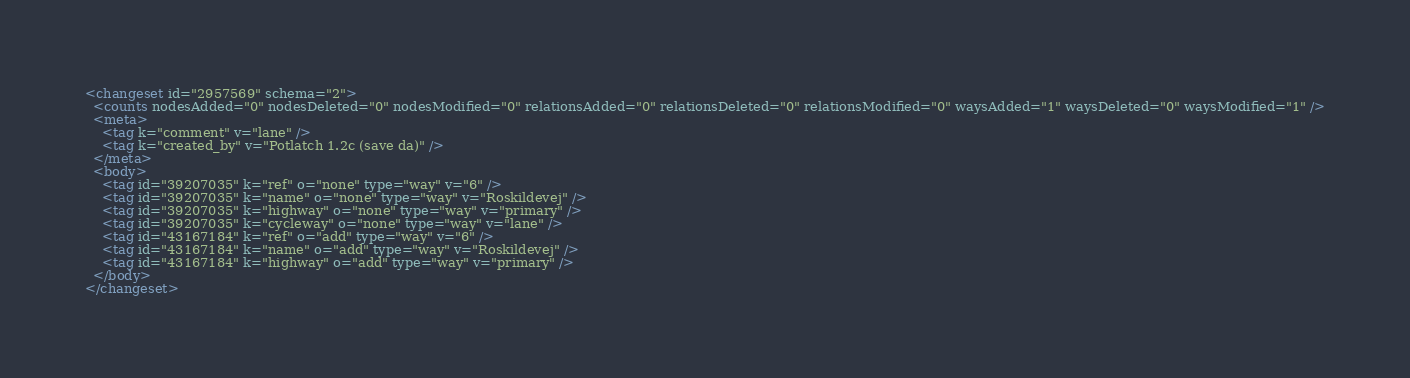<code> <loc_0><loc_0><loc_500><loc_500><_XML_><changeset id="2957569" schema="2">
  <counts nodesAdded="0" nodesDeleted="0" nodesModified="0" relationsAdded="0" relationsDeleted="0" relationsModified="0" waysAdded="1" waysDeleted="0" waysModified="1" />
  <meta>
    <tag k="comment" v="lane" />
    <tag k="created_by" v="Potlatch 1.2c (save da)" />
  </meta>
  <body>
    <tag id="39207035" k="ref" o="none" type="way" v="6" />
    <tag id="39207035" k="name" o="none" type="way" v="Roskildevej" />
    <tag id="39207035" k="highway" o="none" type="way" v="primary" />
    <tag id="39207035" k="cycleway" o="none" type="way" v="lane" />
    <tag id="43167184" k="ref" o="add" type="way" v="6" />
    <tag id="43167184" k="name" o="add" type="way" v="Roskildevej" />
    <tag id="43167184" k="highway" o="add" type="way" v="primary" />
  </body>
</changeset>
</code> 